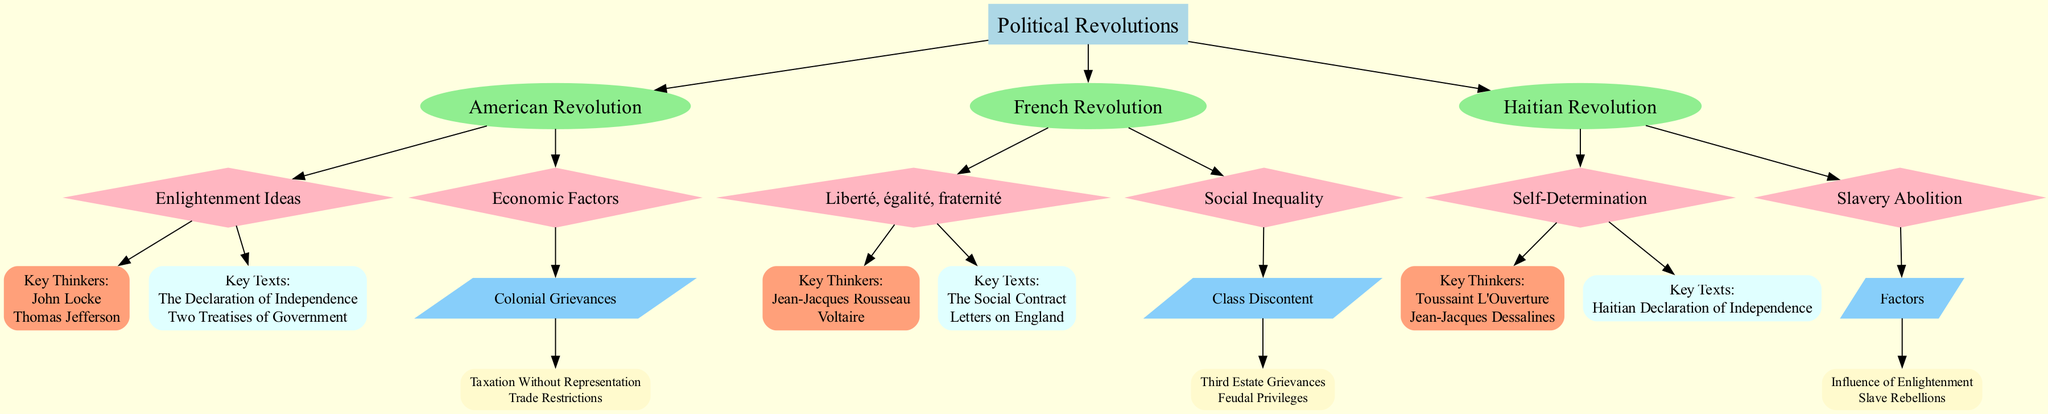What are the three political revolutions depicted in the diagram? The diagram outlines three revolutions: the American Revolution, the French Revolution, and the Haitian Revolution. Each of these is represented as a separate node connected to the root "Political Revolutions."
Answer: American Revolution, French Revolution, Haitian Revolution Who is a key thinker associated with the French Revolution? The diagram shows Jean-Jacques Rousseau and Voltaire as key thinkers linked to the French Revolution under the ideological root "Liberté, égalité, fraternité." Selecting one of these names answers the question directly.
Answer: Jean-Jacques Rousseau What is the primary economic factor listed for the American Revolution? The "Economic Factors" node for the American Revolution connects specifically to "Colonial Grievances," which includes details that mention "Taxation Without Representation" and "Trade Restrictions." Therefore, this answers the query about the main economic issue.
Answer: Colonial Grievances How many key texts are associated with the ideological roots of the Haitian Revolution? The "Self-Determination" ideological root for the Haitian Revolution lists one key text: "Haitian Declaration of Independence." This analysis reveals the quantity related to that specific ideology.
Answer: 1 What ideological concept is linked to the ideology of "Social Inequality" in the French Revolution? The diagram connects "Social Inequality" to the "Class Discontent," which describes "Third Estate Grievances" and "Feudal Privileges." To formulate an answer, refer specifically to this relationship.
Answer: Class Discontent What is the relationship between Enlightenment Ideas and the American Revolution? The diagram shows that Enlightenment Ideas contribute to the ideological roots of the American Revolution, specifically by designating a node that encompasses "Key Thinkers" and "Key Texts" associated with those ideas. This infers that Enlightenment principles were pivotal to the revolution's ideological foundation.
Answer: Contributes to ideological roots Which key thinker is associated with "Self-Determination" in the Haitian Revolution? Looking at the node that corresponds to "Self-Determination," we see two names: Toussaint L'Ouverture and Jean-Jacques Dessalines. Consequently, we can identify one of these thinkers to directly answer the question.
Answer: Toussaint L'Ouverture How many ideological roots does the French Revolution have listed in the diagram? The diagram indicates that there are two main ideological roots under the French Revolution: "Liberté, égalité, fraternité" and "Social Inequality." Thus, this illustrates a straightforward count of ideological concepts.
Answer: 2 What is the key text linked to "Liberté, égalité, fraternité"? The node detailing "Liberté, égalité, fraternité" specifically highlights two key texts: "The Social Contract" and "Letters on England." This indicates that any mention of key texts associated with this ideology would fall under these titles.
Answer: The Social Contract, Letters on England 